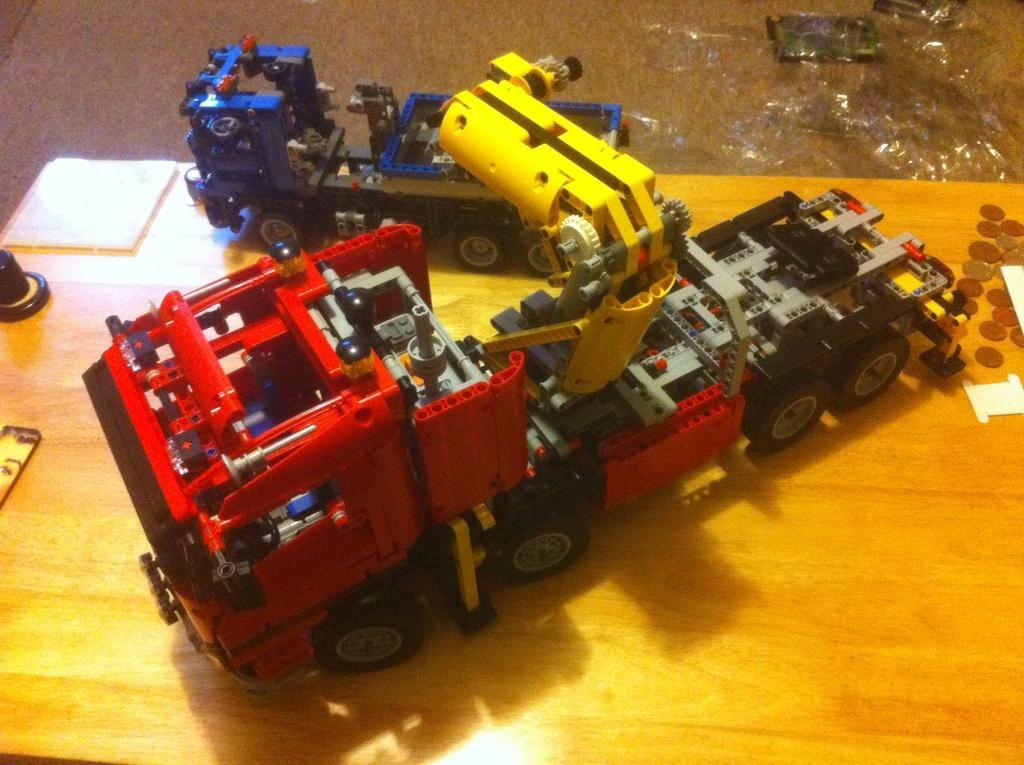How would you summarize this image in a sentence or two? In this picture I can see the toys which looks like the trucks. This toys are kept on the table. Beside that I can see the coins and papers. On the top right corner I can see the plastic covers. 